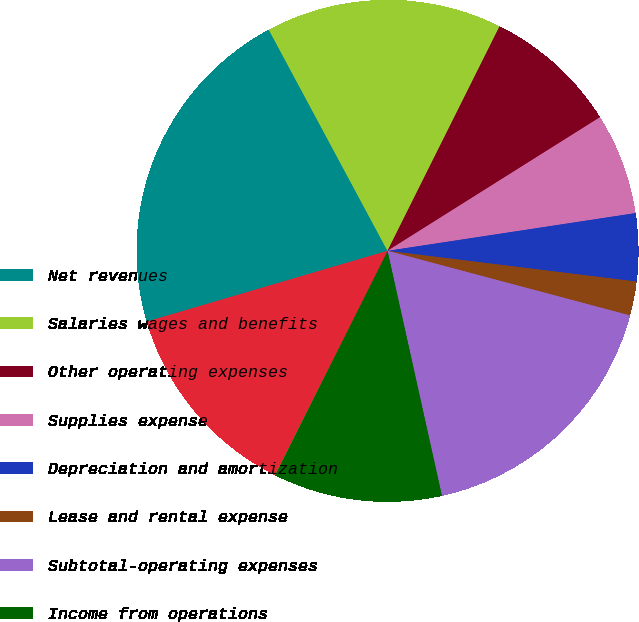<chart> <loc_0><loc_0><loc_500><loc_500><pie_chart><fcel>Net revenues<fcel>Salaries wages and benefits<fcel>Other operating expenses<fcel>Supplies expense<fcel>Depreciation and amortization<fcel>Lease and rental expense<fcel>Subtotal-operating expenses<fcel>Income from operations<fcel>Interest expense net<fcel>Income before income taxes<nl><fcel>21.71%<fcel>15.21%<fcel>8.7%<fcel>6.53%<fcel>4.36%<fcel>2.19%<fcel>17.38%<fcel>10.87%<fcel>0.02%<fcel>13.04%<nl></chart> 